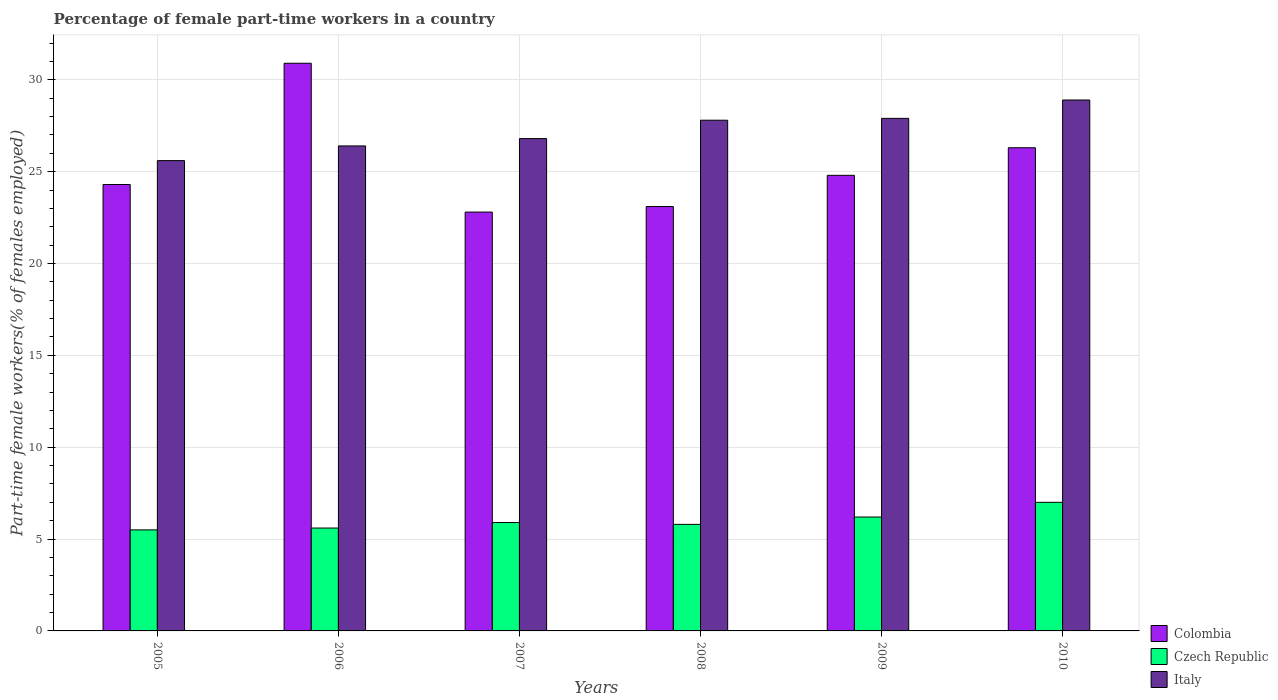How many different coloured bars are there?
Give a very brief answer. 3. How many groups of bars are there?
Offer a terse response. 6. Are the number of bars on each tick of the X-axis equal?
Your response must be concise. Yes. How many bars are there on the 6th tick from the right?
Your response must be concise. 3. What is the percentage of female part-time workers in Colombia in 2008?
Your answer should be compact. 23.1. Across all years, what is the maximum percentage of female part-time workers in Colombia?
Ensure brevity in your answer.  30.9. Across all years, what is the minimum percentage of female part-time workers in Colombia?
Ensure brevity in your answer.  22.8. In which year was the percentage of female part-time workers in Italy maximum?
Offer a terse response. 2010. What is the total percentage of female part-time workers in Colombia in the graph?
Your answer should be compact. 152.2. What is the difference between the percentage of female part-time workers in Colombia in 2006 and that in 2010?
Offer a terse response. 4.6. What is the difference between the percentage of female part-time workers in Colombia in 2007 and the percentage of female part-time workers in Italy in 2005?
Your answer should be very brief. -2.8. In the year 2008, what is the difference between the percentage of female part-time workers in Czech Republic and percentage of female part-time workers in Colombia?
Ensure brevity in your answer.  -17.3. What is the ratio of the percentage of female part-time workers in Italy in 2005 to that in 2008?
Make the answer very short. 0.92. What is the difference between the highest and the lowest percentage of female part-time workers in Italy?
Your response must be concise. 3.3. In how many years, is the percentage of female part-time workers in Czech Republic greater than the average percentage of female part-time workers in Czech Republic taken over all years?
Offer a terse response. 2. Is the sum of the percentage of female part-time workers in Italy in 2005 and 2008 greater than the maximum percentage of female part-time workers in Czech Republic across all years?
Provide a short and direct response. Yes. What does the 1st bar from the left in 2008 represents?
Offer a very short reply. Colombia. What does the 2nd bar from the right in 2006 represents?
Give a very brief answer. Czech Republic. Is it the case that in every year, the sum of the percentage of female part-time workers in Czech Republic and percentage of female part-time workers in Italy is greater than the percentage of female part-time workers in Colombia?
Offer a terse response. Yes. How many bars are there?
Make the answer very short. 18. What is the difference between two consecutive major ticks on the Y-axis?
Provide a succinct answer. 5. Are the values on the major ticks of Y-axis written in scientific E-notation?
Offer a terse response. No. Does the graph contain any zero values?
Provide a short and direct response. No. How are the legend labels stacked?
Your answer should be very brief. Vertical. What is the title of the graph?
Provide a succinct answer. Percentage of female part-time workers in a country. Does "Latin America(developing only)" appear as one of the legend labels in the graph?
Your response must be concise. No. What is the label or title of the Y-axis?
Your answer should be very brief. Part-time female workers(% of females employed). What is the Part-time female workers(% of females employed) in Colombia in 2005?
Offer a terse response. 24.3. What is the Part-time female workers(% of females employed) in Italy in 2005?
Make the answer very short. 25.6. What is the Part-time female workers(% of females employed) in Colombia in 2006?
Make the answer very short. 30.9. What is the Part-time female workers(% of females employed) of Czech Republic in 2006?
Ensure brevity in your answer.  5.6. What is the Part-time female workers(% of females employed) in Italy in 2006?
Provide a short and direct response. 26.4. What is the Part-time female workers(% of females employed) in Colombia in 2007?
Keep it short and to the point. 22.8. What is the Part-time female workers(% of females employed) of Czech Republic in 2007?
Make the answer very short. 5.9. What is the Part-time female workers(% of females employed) of Italy in 2007?
Keep it short and to the point. 26.8. What is the Part-time female workers(% of females employed) in Colombia in 2008?
Provide a succinct answer. 23.1. What is the Part-time female workers(% of females employed) of Czech Republic in 2008?
Offer a terse response. 5.8. What is the Part-time female workers(% of females employed) in Italy in 2008?
Give a very brief answer. 27.8. What is the Part-time female workers(% of females employed) in Colombia in 2009?
Your answer should be compact. 24.8. What is the Part-time female workers(% of females employed) of Czech Republic in 2009?
Provide a short and direct response. 6.2. What is the Part-time female workers(% of females employed) in Italy in 2009?
Your response must be concise. 27.9. What is the Part-time female workers(% of females employed) of Colombia in 2010?
Offer a terse response. 26.3. What is the Part-time female workers(% of females employed) of Italy in 2010?
Provide a succinct answer. 28.9. Across all years, what is the maximum Part-time female workers(% of females employed) of Colombia?
Ensure brevity in your answer.  30.9. Across all years, what is the maximum Part-time female workers(% of females employed) in Czech Republic?
Offer a terse response. 7. Across all years, what is the maximum Part-time female workers(% of females employed) in Italy?
Offer a terse response. 28.9. Across all years, what is the minimum Part-time female workers(% of females employed) in Colombia?
Your answer should be compact. 22.8. Across all years, what is the minimum Part-time female workers(% of females employed) of Italy?
Provide a succinct answer. 25.6. What is the total Part-time female workers(% of females employed) of Colombia in the graph?
Provide a short and direct response. 152.2. What is the total Part-time female workers(% of females employed) in Italy in the graph?
Provide a succinct answer. 163.4. What is the difference between the Part-time female workers(% of females employed) in Czech Republic in 2005 and that in 2006?
Your answer should be compact. -0.1. What is the difference between the Part-time female workers(% of females employed) in Italy in 2005 and that in 2007?
Keep it short and to the point. -1.2. What is the difference between the Part-time female workers(% of females employed) in Colombia in 2005 and that in 2009?
Ensure brevity in your answer.  -0.5. What is the difference between the Part-time female workers(% of females employed) of Czech Republic in 2005 and that in 2010?
Your response must be concise. -1.5. What is the difference between the Part-time female workers(% of females employed) in Italy in 2005 and that in 2010?
Make the answer very short. -3.3. What is the difference between the Part-time female workers(% of females employed) in Colombia in 2006 and that in 2007?
Your answer should be very brief. 8.1. What is the difference between the Part-time female workers(% of females employed) of Czech Republic in 2006 and that in 2008?
Your answer should be very brief. -0.2. What is the difference between the Part-time female workers(% of females employed) of Italy in 2006 and that in 2008?
Ensure brevity in your answer.  -1.4. What is the difference between the Part-time female workers(% of females employed) of Italy in 2006 and that in 2009?
Your answer should be very brief. -1.5. What is the difference between the Part-time female workers(% of females employed) of Czech Republic in 2006 and that in 2010?
Your answer should be very brief. -1.4. What is the difference between the Part-time female workers(% of females employed) in Czech Republic in 2007 and that in 2008?
Provide a succinct answer. 0.1. What is the difference between the Part-time female workers(% of females employed) of Italy in 2007 and that in 2008?
Make the answer very short. -1. What is the difference between the Part-time female workers(% of females employed) of Colombia in 2007 and that in 2009?
Your answer should be very brief. -2. What is the difference between the Part-time female workers(% of females employed) of Czech Republic in 2007 and that in 2010?
Offer a very short reply. -1.1. What is the difference between the Part-time female workers(% of females employed) in Czech Republic in 2008 and that in 2009?
Your answer should be very brief. -0.4. What is the difference between the Part-time female workers(% of females employed) of Italy in 2008 and that in 2010?
Make the answer very short. -1.1. What is the difference between the Part-time female workers(% of females employed) in Italy in 2009 and that in 2010?
Give a very brief answer. -1. What is the difference between the Part-time female workers(% of females employed) in Colombia in 2005 and the Part-time female workers(% of females employed) in Czech Republic in 2006?
Provide a succinct answer. 18.7. What is the difference between the Part-time female workers(% of females employed) of Colombia in 2005 and the Part-time female workers(% of females employed) of Italy in 2006?
Offer a terse response. -2.1. What is the difference between the Part-time female workers(% of females employed) of Czech Republic in 2005 and the Part-time female workers(% of females employed) of Italy in 2006?
Your answer should be compact. -20.9. What is the difference between the Part-time female workers(% of females employed) in Colombia in 2005 and the Part-time female workers(% of females employed) in Italy in 2007?
Your response must be concise. -2.5. What is the difference between the Part-time female workers(% of females employed) in Czech Republic in 2005 and the Part-time female workers(% of females employed) in Italy in 2007?
Your answer should be very brief. -21.3. What is the difference between the Part-time female workers(% of females employed) of Colombia in 2005 and the Part-time female workers(% of females employed) of Czech Republic in 2008?
Your answer should be very brief. 18.5. What is the difference between the Part-time female workers(% of females employed) of Colombia in 2005 and the Part-time female workers(% of females employed) of Italy in 2008?
Offer a terse response. -3.5. What is the difference between the Part-time female workers(% of females employed) in Czech Republic in 2005 and the Part-time female workers(% of females employed) in Italy in 2008?
Your answer should be very brief. -22.3. What is the difference between the Part-time female workers(% of females employed) of Czech Republic in 2005 and the Part-time female workers(% of females employed) of Italy in 2009?
Make the answer very short. -22.4. What is the difference between the Part-time female workers(% of females employed) in Colombia in 2005 and the Part-time female workers(% of females employed) in Czech Republic in 2010?
Keep it short and to the point. 17.3. What is the difference between the Part-time female workers(% of females employed) in Czech Republic in 2005 and the Part-time female workers(% of females employed) in Italy in 2010?
Give a very brief answer. -23.4. What is the difference between the Part-time female workers(% of females employed) in Colombia in 2006 and the Part-time female workers(% of females employed) in Italy in 2007?
Offer a very short reply. 4.1. What is the difference between the Part-time female workers(% of females employed) of Czech Republic in 2006 and the Part-time female workers(% of females employed) of Italy in 2007?
Offer a very short reply. -21.2. What is the difference between the Part-time female workers(% of females employed) of Colombia in 2006 and the Part-time female workers(% of females employed) of Czech Republic in 2008?
Give a very brief answer. 25.1. What is the difference between the Part-time female workers(% of females employed) in Czech Republic in 2006 and the Part-time female workers(% of females employed) in Italy in 2008?
Ensure brevity in your answer.  -22.2. What is the difference between the Part-time female workers(% of females employed) in Colombia in 2006 and the Part-time female workers(% of females employed) in Czech Republic in 2009?
Offer a very short reply. 24.7. What is the difference between the Part-time female workers(% of females employed) in Colombia in 2006 and the Part-time female workers(% of females employed) in Italy in 2009?
Provide a succinct answer. 3. What is the difference between the Part-time female workers(% of females employed) in Czech Republic in 2006 and the Part-time female workers(% of females employed) in Italy in 2009?
Provide a succinct answer. -22.3. What is the difference between the Part-time female workers(% of females employed) of Colombia in 2006 and the Part-time female workers(% of females employed) of Czech Republic in 2010?
Offer a very short reply. 23.9. What is the difference between the Part-time female workers(% of females employed) in Czech Republic in 2006 and the Part-time female workers(% of females employed) in Italy in 2010?
Give a very brief answer. -23.3. What is the difference between the Part-time female workers(% of females employed) of Czech Republic in 2007 and the Part-time female workers(% of females employed) of Italy in 2008?
Your response must be concise. -21.9. What is the difference between the Part-time female workers(% of females employed) of Colombia in 2007 and the Part-time female workers(% of females employed) of Italy in 2009?
Ensure brevity in your answer.  -5.1. What is the difference between the Part-time female workers(% of females employed) of Colombia in 2007 and the Part-time female workers(% of females employed) of Italy in 2010?
Provide a short and direct response. -6.1. What is the difference between the Part-time female workers(% of females employed) in Czech Republic in 2007 and the Part-time female workers(% of females employed) in Italy in 2010?
Offer a terse response. -23. What is the difference between the Part-time female workers(% of females employed) of Colombia in 2008 and the Part-time female workers(% of females employed) of Italy in 2009?
Offer a terse response. -4.8. What is the difference between the Part-time female workers(% of females employed) in Czech Republic in 2008 and the Part-time female workers(% of females employed) in Italy in 2009?
Ensure brevity in your answer.  -22.1. What is the difference between the Part-time female workers(% of females employed) of Colombia in 2008 and the Part-time female workers(% of females employed) of Czech Republic in 2010?
Give a very brief answer. 16.1. What is the difference between the Part-time female workers(% of females employed) of Colombia in 2008 and the Part-time female workers(% of females employed) of Italy in 2010?
Provide a short and direct response. -5.8. What is the difference between the Part-time female workers(% of females employed) of Czech Republic in 2008 and the Part-time female workers(% of females employed) of Italy in 2010?
Keep it short and to the point. -23.1. What is the difference between the Part-time female workers(% of females employed) in Colombia in 2009 and the Part-time female workers(% of females employed) in Czech Republic in 2010?
Your response must be concise. 17.8. What is the difference between the Part-time female workers(% of females employed) in Colombia in 2009 and the Part-time female workers(% of females employed) in Italy in 2010?
Your answer should be compact. -4.1. What is the difference between the Part-time female workers(% of females employed) in Czech Republic in 2009 and the Part-time female workers(% of females employed) in Italy in 2010?
Provide a short and direct response. -22.7. What is the average Part-time female workers(% of females employed) of Colombia per year?
Give a very brief answer. 25.37. What is the average Part-time female workers(% of females employed) of Czech Republic per year?
Offer a terse response. 6. What is the average Part-time female workers(% of females employed) in Italy per year?
Your response must be concise. 27.23. In the year 2005, what is the difference between the Part-time female workers(% of females employed) in Czech Republic and Part-time female workers(% of females employed) in Italy?
Give a very brief answer. -20.1. In the year 2006, what is the difference between the Part-time female workers(% of females employed) of Colombia and Part-time female workers(% of females employed) of Czech Republic?
Your response must be concise. 25.3. In the year 2006, what is the difference between the Part-time female workers(% of females employed) of Czech Republic and Part-time female workers(% of females employed) of Italy?
Your answer should be compact. -20.8. In the year 2007, what is the difference between the Part-time female workers(% of females employed) in Colombia and Part-time female workers(% of females employed) in Czech Republic?
Provide a succinct answer. 16.9. In the year 2007, what is the difference between the Part-time female workers(% of females employed) of Colombia and Part-time female workers(% of females employed) of Italy?
Provide a succinct answer. -4. In the year 2007, what is the difference between the Part-time female workers(% of females employed) of Czech Republic and Part-time female workers(% of females employed) of Italy?
Your response must be concise. -20.9. In the year 2008, what is the difference between the Part-time female workers(% of females employed) in Czech Republic and Part-time female workers(% of females employed) in Italy?
Keep it short and to the point. -22. In the year 2009, what is the difference between the Part-time female workers(% of females employed) of Colombia and Part-time female workers(% of females employed) of Czech Republic?
Your response must be concise. 18.6. In the year 2009, what is the difference between the Part-time female workers(% of females employed) of Czech Republic and Part-time female workers(% of females employed) of Italy?
Give a very brief answer. -21.7. In the year 2010, what is the difference between the Part-time female workers(% of females employed) in Colombia and Part-time female workers(% of females employed) in Czech Republic?
Keep it short and to the point. 19.3. In the year 2010, what is the difference between the Part-time female workers(% of females employed) of Colombia and Part-time female workers(% of females employed) of Italy?
Offer a terse response. -2.6. In the year 2010, what is the difference between the Part-time female workers(% of females employed) of Czech Republic and Part-time female workers(% of females employed) of Italy?
Your answer should be very brief. -21.9. What is the ratio of the Part-time female workers(% of females employed) of Colombia in 2005 to that in 2006?
Give a very brief answer. 0.79. What is the ratio of the Part-time female workers(% of females employed) of Czech Republic in 2005 to that in 2006?
Offer a terse response. 0.98. What is the ratio of the Part-time female workers(% of females employed) in Italy in 2005 to that in 2006?
Offer a very short reply. 0.97. What is the ratio of the Part-time female workers(% of females employed) of Colombia in 2005 to that in 2007?
Provide a short and direct response. 1.07. What is the ratio of the Part-time female workers(% of females employed) of Czech Republic in 2005 to that in 2007?
Your answer should be very brief. 0.93. What is the ratio of the Part-time female workers(% of females employed) in Italy in 2005 to that in 2007?
Keep it short and to the point. 0.96. What is the ratio of the Part-time female workers(% of females employed) of Colombia in 2005 to that in 2008?
Your answer should be compact. 1.05. What is the ratio of the Part-time female workers(% of females employed) of Czech Republic in 2005 to that in 2008?
Offer a very short reply. 0.95. What is the ratio of the Part-time female workers(% of females employed) of Italy in 2005 to that in 2008?
Make the answer very short. 0.92. What is the ratio of the Part-time female workers(% of females employed) in Colombia in 2005 to that in 2009?
Make the answer very short. 0.98. What is the ratio of the Part-time female workers(% of females employed) of Czech Republic in 2005 to that in 2009?
Ensure brevity in your answer.  0.89. What is the ratio of the Part-time female workers(% of females employed) in Italy in 2005 to that in 2009?
Provide a short and direct response. 0.92. What is the ratio of the Part-time female workers(% of females employed) in Colombia in 2005 to that in 2010?
Your answer should be very brief. 0.92. What is the ratio of the Part-time female workers(% of females employed) in Czech Republic in 2005 to that in 2010?
Make the answer very short. 0.79. What is the ratio of the Part-time female workers(% of females employed) of Italy in 2005 to that in 2010?
Provide a short and direct response. 0.89. What is the ratio of the Part-time female workers(% of females employed) of Colombia in 2006 to that in 2007?
Make the answer very short. 1.36. What is the ratio of the Part-time female workers(% of females employed) of Czech Republic in 2006 to that in 2007?
Offer a terse response. 0.95. What is the ratio of the Part-time female workers(% of females employed) of Italy in 2006 to that in 2007?
Offer a terse response. 0.99. What is the ratio of the Part-time female workers(% of females employed) of Colombia in 2006 to that in 2008?
Offer a terse response. 1.34. What is the ratio of the Part-time female workers(% of females employed) of Czech Republic in 2006 to that in 2008?
Ensure brevity in your answer.  0.97. What is the ratio of the Part-time female workers(% of females employed) of Italy in 2006 to that in 2008?
Your answer should be very brief. 0.95. What is the ratio of the Part-time female workers(% of females employed) in Colombia in 2006 to that in 2009?
Offer a very short reply. 1.25. What is the ratio of the Part-time female workers(% of females employed) of Czech Republic in 2006 to that in 2009?
Keep it short and to the point. 0.9. What is the ratio of the Part-time female workers(% of females employed) in Italy in 2006 to that in 2009?
Make the answer very short. 0.95. What is the ratio of the Part-time female workers(% of females employed) in Colombia in 2006 to that in 2010?
Give a very brief answer. 1.17. What is the ratio of the Part-time female workers(% of females employed) of Italy in 2006 to that in 2010?
Provide a short and direct response. 0.91. What is the ratio of the Part-time female workers(% of females employed) in Czech Republic in 2007 to that in 2008?
Give a very brief answer. 1.02. What is the ratio of the Part-time female workers(% of females employed) in Colombia in 2007 to that in 2009?
Offer a terse response. 0.92. What is the ratio of the Part-time female workers(% of females employed) in Czech Republic in 2007 to that in 2009?
Offer a very short reply. 0.95. What is the ratio of the Part-time female workers(% of females employed) in Italy in 2007 to that in 2009?
Offer a terse response. 0.96. What is the ratio of the Part-time female workers(% of females employed) in Colombia in 2007 to that in 2010?
Ensure brevity in your answer.  0.87. What is the ratio of the Part-time female workers(% of females employed) in Czech Republic in 2007 to that in 2010?
Offer a very short reply. 0.84. What is the ratio of the Part-time female workers(% of females employed) in Italy in 2007 to that in 2010?
Offer a very short reply. 0.93. What is the ratio of the Part-time female workers(% of females employed) in Colombia in 2008 to that in 2009?
Keep it short and to the point. 0.93. What is the ratio of the Part-time female workers(% of females employed) of Czech Republic in 2008 to that in 2009?
Keep it short and to the point. 0.94. What is the ratio of the Part-time female workers(% of females employed) of Italy in 2008 to that in 2009?
Your answer should be compact. 1. What is the ratio of the Part-time female workers(% of females employed) in Colombia in 2008 to that in 2010?
Keep it short and to the point. 0.88. What is the ratio of the Part-time female workers(% of females employed) of Czech Republic in 2008 to that in 2010?
Provide a short and direct response. 0.83. What is the ratio of the Part-time female workers(% of females employed) in Italy in 2008 to that in 2010?
Your response must be concise. 0.96. What is the ratio of the Part-time female workers(% of females employed) in Colombia in 2009 to that in 2010?
Offer a terse response. 0.94. What is the ratio of the Part-time female workers(% of females employed) in Czech Republic in 2009 to that in 2010?
Your answer should be compact. 0.89. What is the ratio of the Part-time female workers(% of females employed) in Italy in 2009 to that in 2010?
Provide a short and direct response. 0.97. What is the difference between the highest and the second highest Part-time female workers(% of females employed) of Colombia?
Make the answer very short. 4.6. What is the difference between the highest and the second highest Part-time female workers(% of females employed) of Italy?
Give a very brief answer. 1. What is the difference between the highest and the lowest Part-time female workers(% of females employed) in Czech Republic?
Your response must be concise. 1.5. 